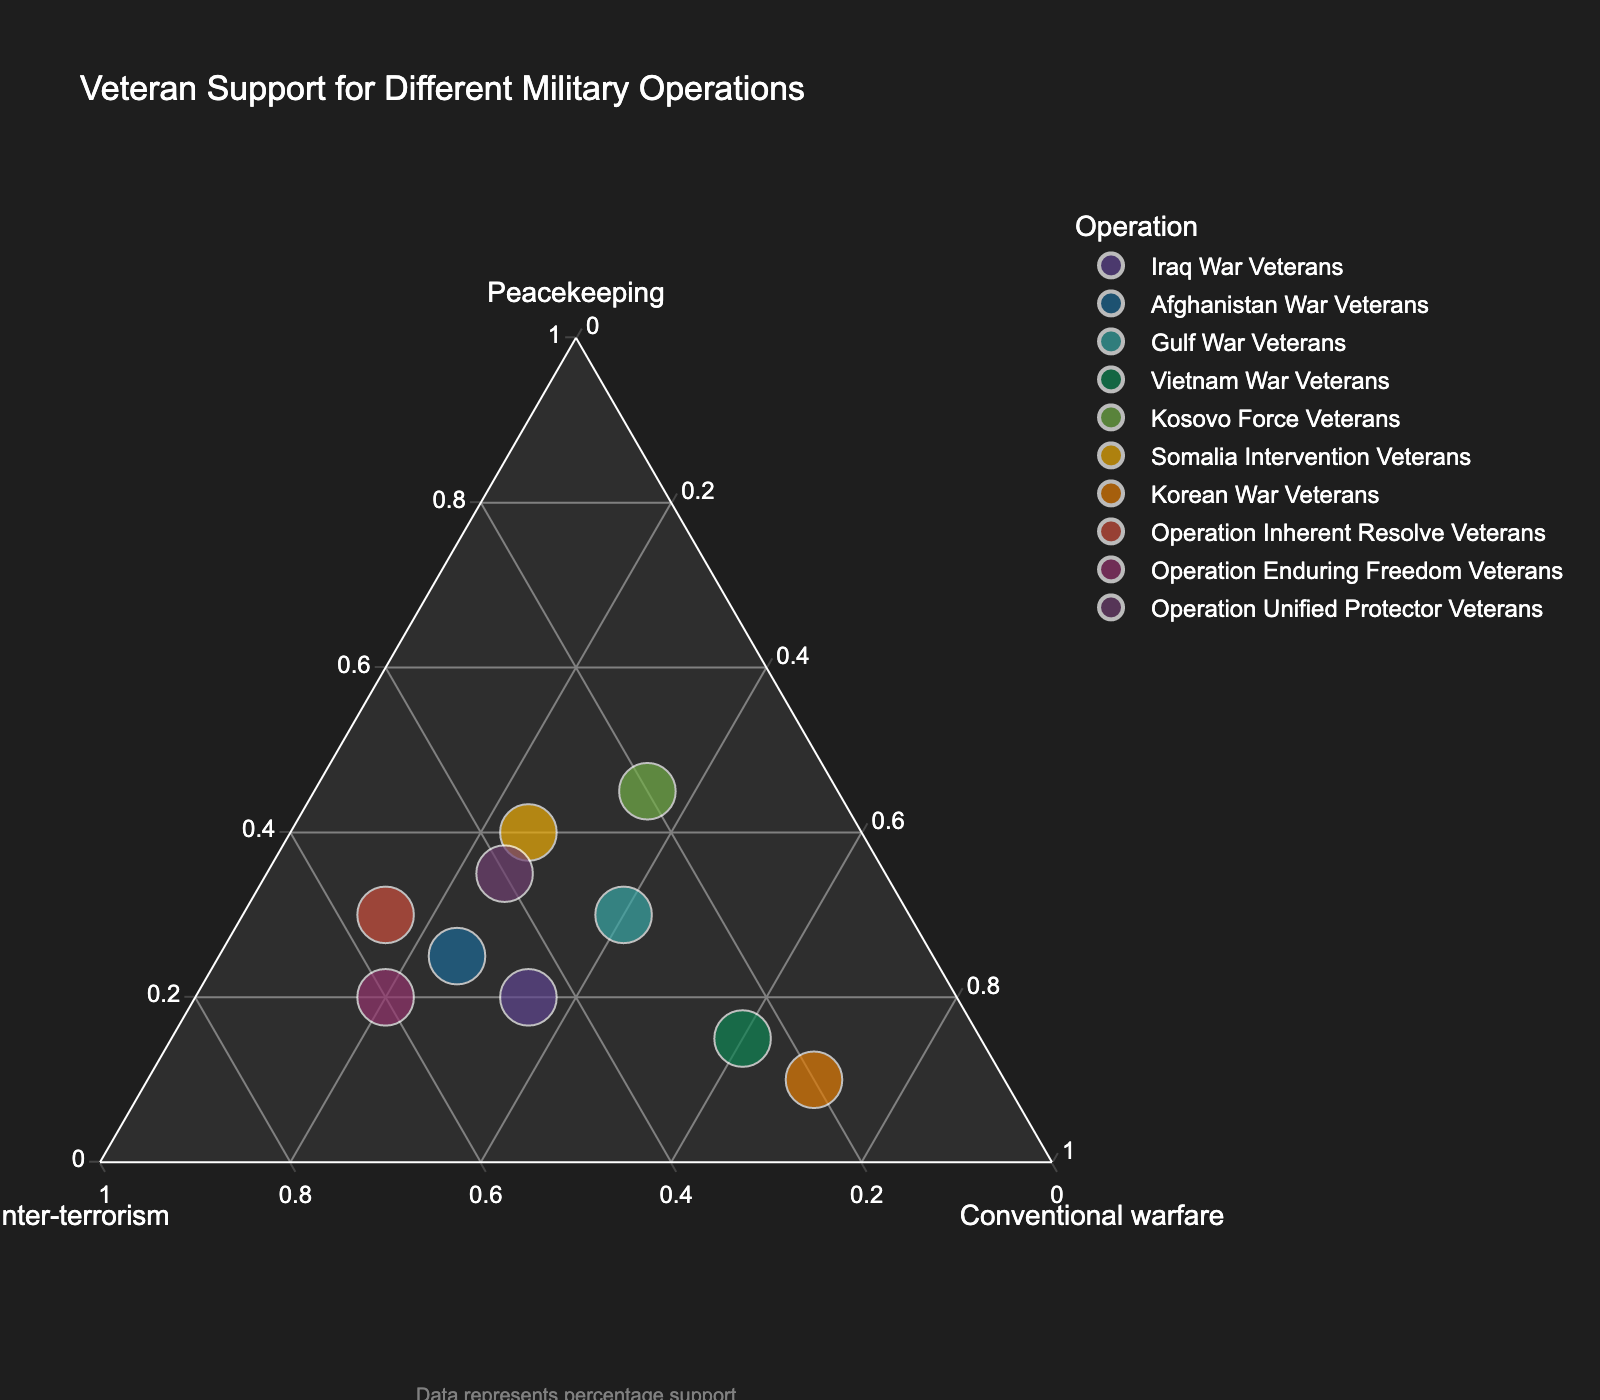What's the title of the plot? The title of the plot can be found at the top of the figure where it is clearly displayed to describe the content of the visual.
Answer: Veteran Support for Different Military Operations How many types of veterans are represented in the plot? Each point in the ternary plot represents a different type of veteran, and counting the points will give the total number of types.
Answer: 10 Which group has the highest support for conventional warfare? To find which group has the highest support for conventional warfare, you should look for the data point closest to the "Conventional Warfare" vertex of the ternary plot.
Answer: Korean War Veterans Which veteran group has the least support for peacekeeping? The group with the least support for peacekeeping will be the data point closest to the opposite side of the "Peacekeeping" vertex.
Answer: Korean War Veterans Are there any veterans with equal support for counter-terrorism and conventional warfare? Examine each point's a and b values to see if any points have equal values for "Counter-terrorism" and "Conventional Warfare".
Answer: No Which operation has the highest support for counter-terrorism? Identify the point nearest to the "Counter-terrorism" vertex; this point represents the operation with the highest support for counter-terrorism.
Answer: Operation Enduring Freedom Veterans Is there any veteran group that shows greater support for peacekeeping than for conventional warfare? Compare the peacekeeping and conventional warfare values for each group to find any groups where the peacekeeping value is higher.
Answer: Yes, Kosovo Force Veterans What is the sum of the percentages for the Somalia Intervention Veterans? The sum for this veteran type can be calculated by adding the peacekeeping, counter-terrorism, and conventional warfare values: 40 + 35 + 25 = 100.
Answer: 100% Do any operations have balanced support across all three types of military operations? Check for points that are roughly equidistant from all three vertices, indicating balanced support.
Answer: No Which group shows a higher preference for counter-terrorism, Afghanistan War Veterans or Operation Inherent Resolve Veterans? Compare the "Counter-terrorism" values for the two groups: 50 for Afghanistan War Veterans and 55 for Operation Inherent Resolve Veterans.
Answer: Operation Inherent Resolve Veterans 